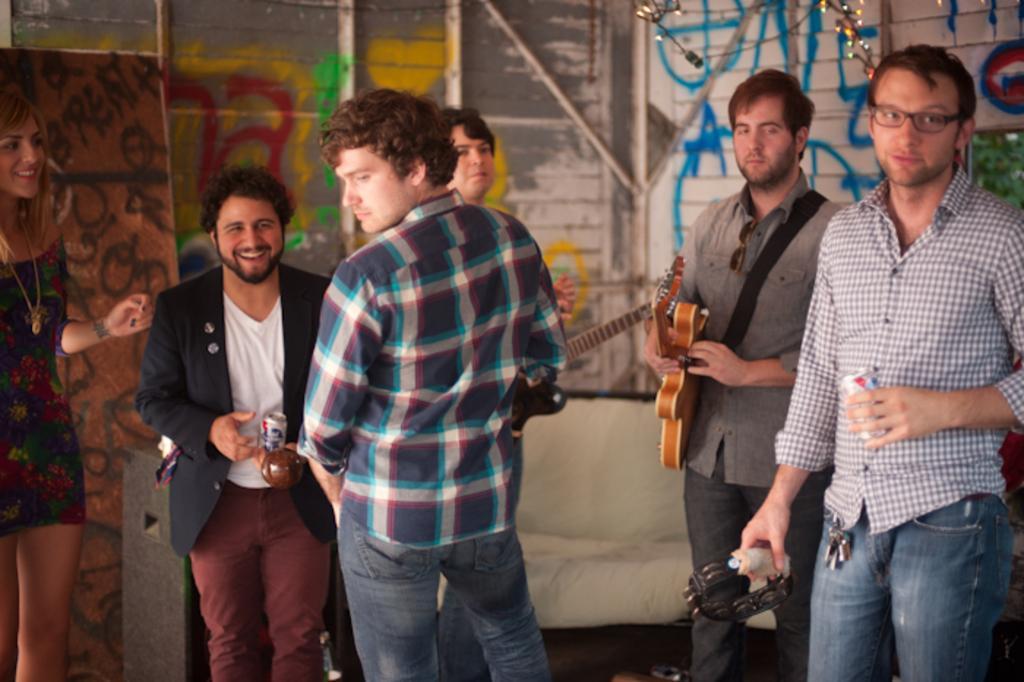Could you give a brief overview of what you see in this image? Here I can see a woman and few men are standing. Two men are holding the guitars. The man who is on the left side is holding a coke-tin in the hand and smiling. This man is facing towards the back side. In the background there is a wall. On the left side there is a board. 